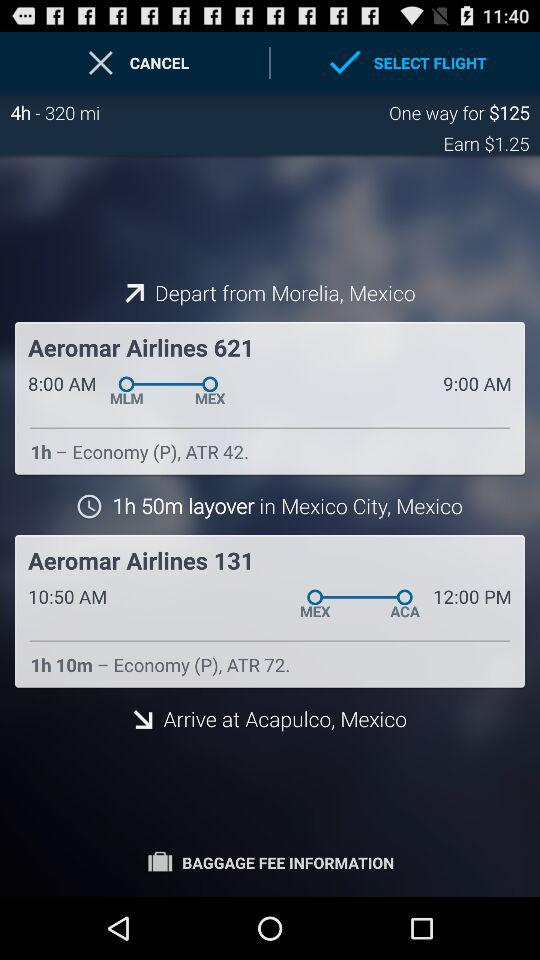What is the earn amount? The earn amount is $1.25. 